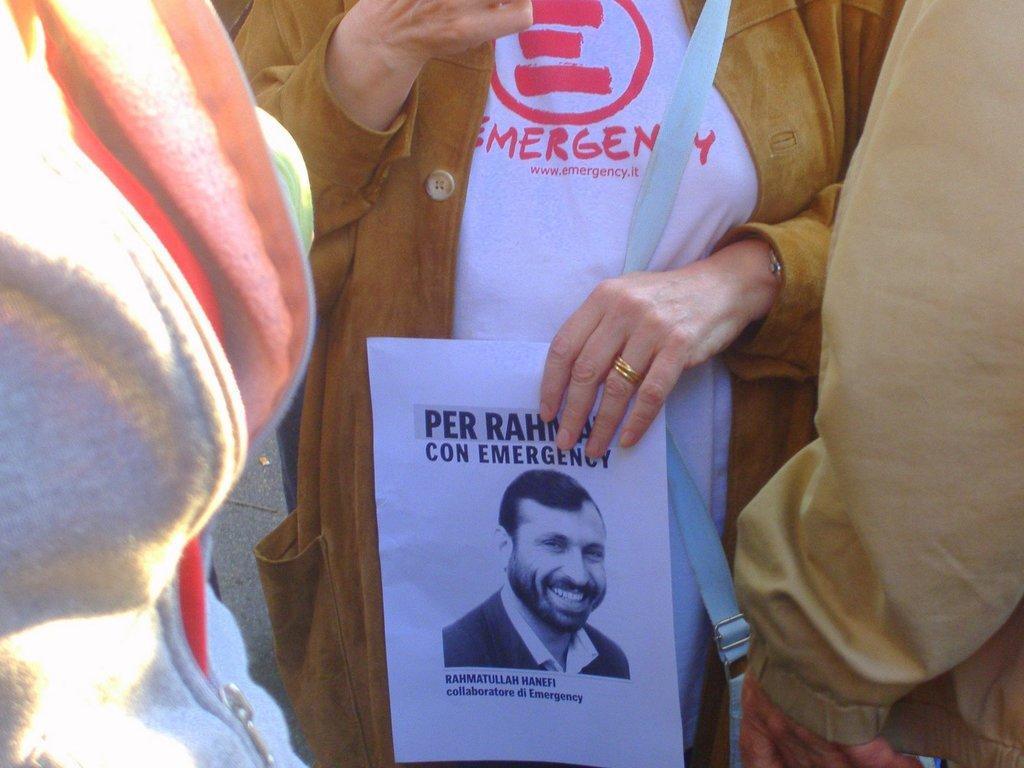Can you describe this image briefly? In this picture I can see in the middle a person is holding the paper, there is an image of a man on this paper. 